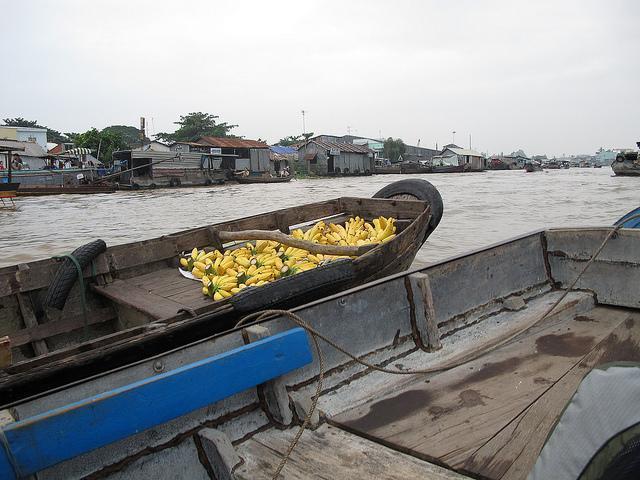What food is on the boat?
Make your selection from the four choices given to correctly answer the question.
Options: Banana, apple, orange, eggplant. Banana. 